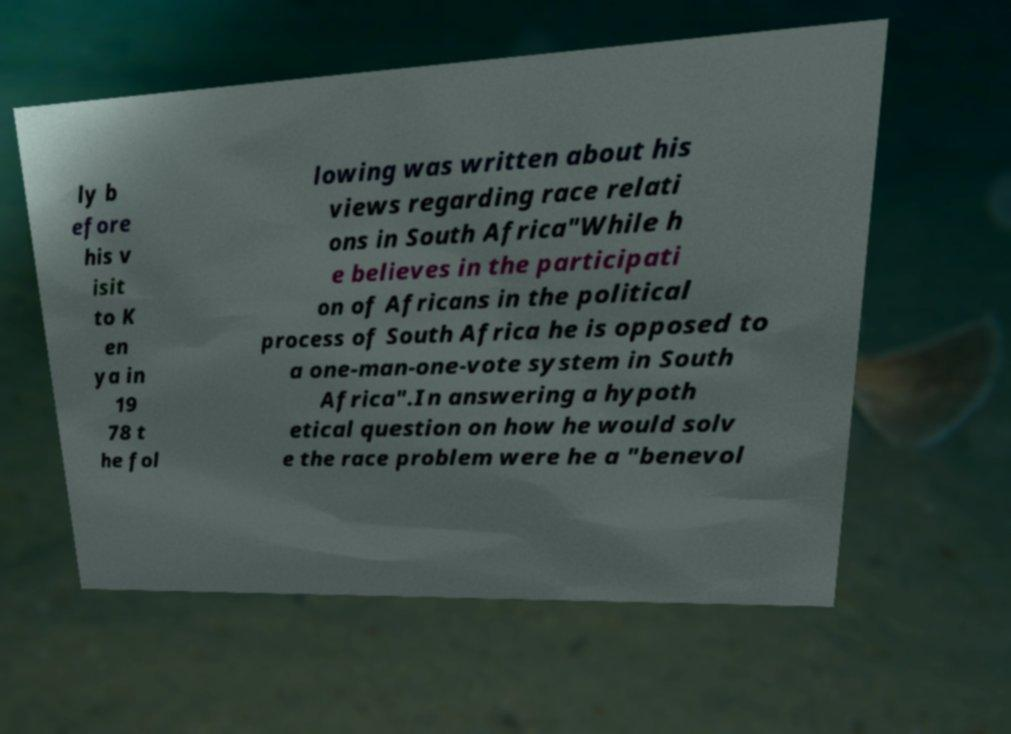I need the written content from this picture converted into text. Can you do that? ly b efore his v isit to K en ya in 19 78 t he fol lowing was written about his views regarding race relati ons in South Africa"While h e believes in the participati on of Africans in the political process of South Africa he is opposed to a one-man-one-vote system in South Africa".In answering a hypoth etical question on how he would solv e the race problem were he a "benevol 